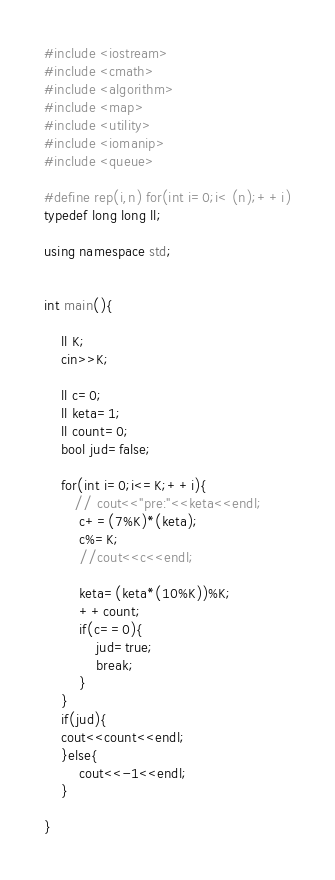Convert code to text. <code><loc_0><loc_0><loc_500><loc_500><_C++_>
#include <iostream>
#include <cmath>
#include <algorithm>
#include <map>
#include <utility>
#include <iomanip>
#include <queue>

#define rep(i,n) for(int i=0;i< (n);++i)
typedef long long ll;

using namespace std;


int main(){
    
    ll K;
    cin>>K;
    
    ll c=0;
    ll keta=1;
    ll count=0;
    bool jud=false;
    
    for(int i=0;i<=K;++i){
       // cout<<"pre:"<<keta<<endl;
        c+=(7%K)*(keta);
        c%=K;
        //cout<<c<<endl;
        
        keta=(keta*(10%K))%K;
        ++count;
        if(c==0){
            jud=true;
            break;
        }
    }
    if(jud){
    cout<<count<<endl;
    }else{
        cout<<-1<<endl;
    }

}

</code> 